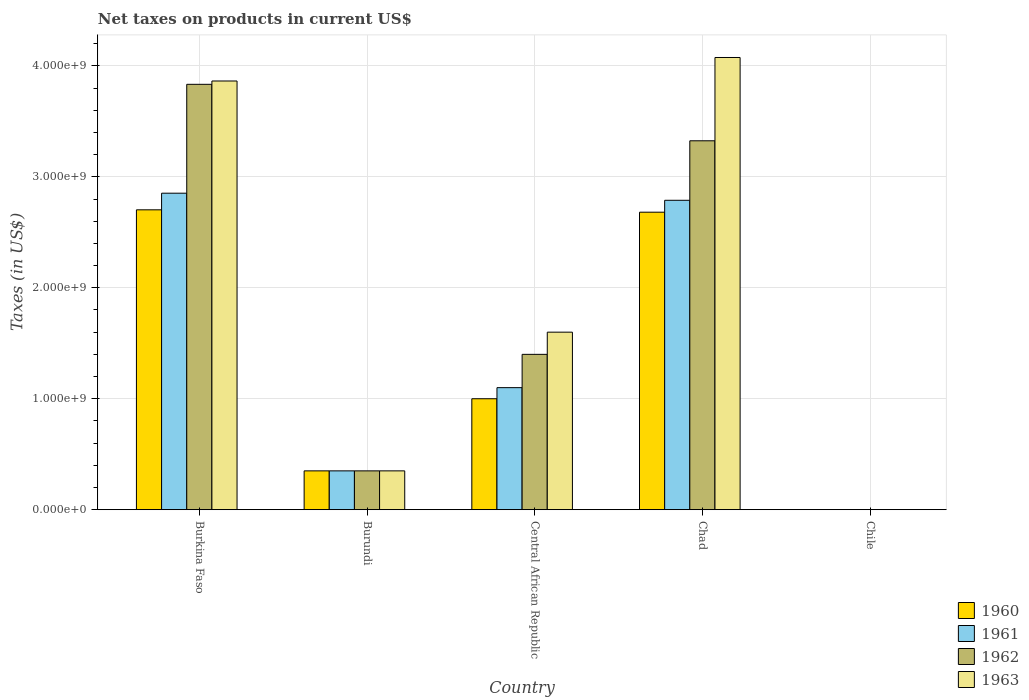How many groups of bars are there?
Ensure brevity in your answer.  5. Are the number of bars per tick equal to the number of legend labels?
Your answer should be compact. Yes. Are the number of bars on each tick of the X-axis equal?
Provide a succinct answer. Yes. What is the label of the 2nd group of bars from the left?
Keep it short and to the point. Burundi. In how many cases, is the number of bars for a given country not equal to the number of legend labels?
Offer a terse response. 0. What is the net taxes on products in 1963 in Chad?
Your answer should be compact. 4.08e+09. Across all countries, what is the maximum net taxes on products in 1962?
Provide a succinct answer. 3.83e+09. Across all countries, what is the minimum net taxes on products in 1962?
Provide a short and direct response. 2.53e+05. In which country was the net taxes on products in 1962 maximum?
Offer a terse response. Burkina Faso. In which country was the net taxes on products in 1963 minimum?
Offer a very short reply. Chile. What is the total net taxes on products in 1960 in the graph?
Ensure brevity in your answer.  6.73e+09. What is the difference between the net taxes on products in 1960 in Burundi and that in Central African Republic?
Offer a terse response. -6.50e+08. What is the difference between the net taxes on products in 1960 in Chile and the net taxes on products in 1962 in Central African Republic?
Keep it short and to the point. -1.40e+09. What is the average net taxes on products in 1962 per country?
Your response must be concise. 1.78e+09. What is the difference between the net taxes on products of/in 1963 and net taxes on products of/in 1962 in Burundi?
Your response must be concise. 0. In how many countries, is the net taxes on products in 1960 greater than 2000000000 US$?
Ensure brevity in your answer.  2. What is the ratio of the net taxes on products in 1963 in Burkina Faso to that in Chad?
Ensure brevity in your answer.  0.95. Is the net taxes on products in 1960 in Burkina Faso less than that in Chad?
Provide a succinct answer. No. What is the difference between the highest and the second highest net taxes on products in 1961?
Provide a short and direct response. 1.75e+09. What is the difference between the highest and the lowest net taxes on products in 1963?
Your response must be concise. 4.08e+09. Is it the case that in every country, the sum of the net taxes on products in 1960 and net taxes on products in 1961 is greater than the net taxes on products in 1963?
Offer a terse response. Yes. How many bars are there?
Keep it short and to the point. 20. How many countries are there in the graph?
Offer a terse response. 5. Are the values on the major ticks of Y-axis written in scientific E-notation?
Your answer should be compact. Yes. Does the graph contain any zero values?
Your answer should be compact. No. Does the graph contain grids?
Give a very brief answer. Yes. What is the title of the graph?
Offer a very short reply. Net taxes on products in current US$. What is the label or title of the Y-axis?
Give a very brief answer. Taxes (in US$). What is the Taxes (in US$) in 1960 in Burkina Faso?
Keep it short and to the point. 2.70e+09. What is the Taxes (in US$) in 1961 in Burkina Faso?
Your answer should be very brief. 2.85e+09. What is the Taxes (in US$) in 1962 in Burkina Faso?
Ensure brevity in your answer.  3.83e+09. What is the Taxes (in US$) in 1963 in Burkina Faso?
Your answer should be very brief. 3.86e+09. What is the Taxes (in US$) of 1960 in Burundi?
Give a very brief answer. 3.50e+08. What is the Taxes (in US$) of 1961 in Burundi?
Ensure brevity in your answer.  3.50e+08. What is the Taxes (in US$) of 1962 in Burundi?
Provide a succinct answer. 3.50e+08. What is the Taxes (in US$) in 1963 in Burundi?
Offer a terse response. 3.50e+08. What is the Taxes (in US$) in 1960 in Central African Republic?
Ensure brevity in your answer.  1.00e+09. What is the Taxes (in US$) of 1961 in Central African Republic?
Your response must be concise. 1.10e+09. What is the Taxes (in US$) in 1962 in Central African Republic?
Ensure brevity in your answer.  1.40e+09. What is the Taxes (in US$) of 1963 in Central African Republic?
Provide a succinct answer. 1.60e+09. What is the Taxes (in US$) of 1960 in Chad?
Your answer should be compact. 2.68e+09. What is the Taxes (in US$) of 1961 in Chad?
Provide a succinct answer. 2.79e+09. What is the Taxes (in US$) of 1962 in Chad?
Provide a short and direct response. 3.32e+09. What is the Taxes (in US$) of 1963 in Chad?
Give a very brief answer. 4.08e+09. What is the Taxes (in US$) of 1960 in Chile?
Give a very brief answer. 2.02e+05. What is the Taxes (in US$) of 1961 in Chile?
Your answer should be very brief. 2.53e+05. What is the Taxes (in US$) in 1962 in Chile?
Ensure brevity in your answer.  2.53e+05. What is the Taxes (in US$) in 1963 in Chile?
Your answer should be compact. 3.54e+05. Across all countries, what is the maximum Taxes (in US$) in 1960?
Provide a succinct answer. 2.70e+09. Across all countries, what is the maximum Taxes (in US$) in 1961?
Provide a succinct answer. 2.85e+09. Across all countries, what is the maximum Taxes (in US$) of 1962?
Provide a short and direct response. 3.83e+09. Across all countries, what is the maximum Taxes (in US$) in 1963?
Give a very brief answer. 4.08e+09. Across all countries, what is the minimum Taxes (in US$) of 1960?
Your answer should be compact. 2.02e+05. Across all countries, what is the minimum Taxes (in US$) of 1961?
Ensure brevity in your answer.  2.53e+05. Across all countries, what is the minimum Taxes (in US$) of 1962?
Ensure brevity in your answer.  2.53e+05. Across all countries, what is the minimum Taxes (in US$) of 1963?
Give a very brief answer. 3.54e+05. What is the total Taxes (in US$) of 1960 in the graph?
Your answer should be compact. 6.73e+09. What is the total Taxes (in US$) in 1961 in the graph?
Ensure brevity in your answer.  7.09e+09. What is the total Taxes (in US$) in 1962 in the graph?
Your answer should be very brief. 8.91e+09. What is the total Taxes (in US$) of 1963 in the graph?
Keep it short and to the point. 9.89e+09. What is the difference between the Taxes (in US$) in 1960 in Burkina Faso and that in Burundi?
Give a very brief answer. 2.35e+09. What is the difference between the Taxes (in US$) of 1961 in Burkina Faso and that in Burundi?
Your response must be concise. 2.50e+09. What is the difference between the Taxes (in US$) in 1962 in Burkina Faso and that in Burundi?
Keep it short and to the point. 3.48e+09. What is the difference between the Taxes (in US$) in 1963 in Burkina Faso and that in Burundi?
Your answer should be very brief. 3.51e+09. What is the difference between the Taxes (in US$) in 1960 in Burkina Faso and that in Central African Republic?
Ensure brevity in your answer.  1.70e+09. What is the difference between the Taxes (in US$) in 1961 in Burkina Faso and that in Central African Republic?
Ensure brevity in your answer.  1.75e+09. What is the difference between the Taxes (in US$) in 1962 in Burkina Faso and that in Central African Republic?
Ensure brevity in your answer.  2.43e+09. What is the difference between the Taxes (in US$) of 1963 in Burkina Faso and that in Central African Republic?
Keep it short and to the point. 2.26e+09. What is the difference between the Taxes (in US$) of 1960 in Burkina Faso and that in Chad?
Keep it short and to the point. 2.13e+07. What is the difference between the Taxes (in US$) in 1961 in Burkina Faso and that in Chad?
Provide a succinct answer. 6.39e+07. What is the difference between the Taxes (in US$) of 1962 in Burkina Faso and that in Chad?
Your response must be concise. 5.09e+08. What is the difference between the Taxes (in US$) in 1963 in Burkina Faso and that in Chad?
Give a very brief answer. -2.12e+08. What is the difference between the Taxes (in US$) of 1960 in Burkina Faso and that in Chile?
Provide a short and direct response. 2.70e+09. What is the difference between the Taxes (in US$) of 1961 in Burkina Faso and that in Chile?
Give a very brief answer. 2.85e+09. What is the difference between the Taxes (in US$) of 1962 in Burkina Faso and that in Chile?
Give a very brief answer. 3.83e+09. What is the difference between the Taxes (in US$) in 1963 in Burkina Faso and that in Chile?
Your answer should be very brief. 3.86e+09. What is the difference between the Taxes (in US$) in 1960 in Burundi and that in Central African Republic?
Make the answer very short. -6.50e+08. What is the difference between the Taxes (in US$) of 1961 in Burundi and that in Central African Republic?
Offer a very short reply. -7.50e+08. What is the difference between the Taxes (in US$) of 1962 in Burundi and that in Central African Republic?
Make the answer very short. -1.05e+09. What is the difference between the Taxes (in US$) in 1963 in Burundi and that in Central African Republic?
Your answer should be very brief. -1.25e+09. What is the difference between the Taxes (in US$) in 1960 in Burundi and that in Chad?
Ensure brevity in your answer.  -2.33e+09. What is the difference between the Taxes (in US$) of 1961 in Burundi and that in Chad?
Your answer should be compact. -2.44e+09. What is the difference between the Taxes (in US$) in 1962 in Burundi and that in Chad?
Keep it short and to the point. -2.97e+09. What is the difference between the Taxes (in US$) of 1963 in Burundi and that in Chad?
Offer a terse response. -3.73e+09. What is the difference between the Taxes (in US$) of 1960 in Burundi and that in Chile?
Provide a succinct answer. 3.50e+08. What is the difference between the Taxes (in US$) of 1961 in Burundi and that in Chile?
Your response must be concise. 3.50e+08. What is the difference between the Taxes (in US$) in 1962 in Burundi and that in Chile?
Offer a very short reply. 3.50e+08. What is the difference between the Taxes (in US$) in 1963 in Burundi and that in Chile?
Offer a very short reply. 3.50e+08. What is the difference between the Taxes (in US$) of 1960 in Central African Republic and that in Chad?
Provide a short and direct response. -1.68e+09. What is the difference between the Taxes (in US$) in 1961 in Central African Republic and that in Chad?
Provide a succinct answer. -1.69e+09. What is the difference between the Taxes (in US$) of 1962 in Central African Republic and that in Chad?
Offer a very short reply. -1.92e+09. What is the difference between the Taxes (in US$) of 1963 in Central African Republic and that in Chad?
Your response must be concise. -2.48e+09. What is the difference between the Taxes (in US$) of 1960 in Central African Republic and that in Chile?
Provide a short and direct response. 1.00e+09. What is the difference between the Taxes (in US$) of 1961 in Central African Republic and that in Chile?
Offer a terse response. 1.10e+09. What is the difference between the Taxes (in US$) in 1962 in Central African Republic and that in Chile?
Your response must be concise. 1.40e+09. What is the difference between the Taxes (in US$) of 1963 in Central African Republic and that in Chile?
Keep it short and to the point. 1.60e+09. What is the difference between the Taxes (in US$) in 1960 in Chad and that in Chile?
Keep it short and to the point. 2.68e+09. What is the difference between the Taxes (in US$) in 1961 in Chad and that in Chile?
Offer a terse response. 2.79e+09. What is the difference between the Taxes (in US$) of 1962 in Chad and that in Chile?
Make the answer very short. 3.32e+09. What is the difference between the Taxes (in US$) of 1963 in Chad and that in Chile?
Give a very brief answer. 4.08e+09. What is the difference between the Taxes (in US$) of 1960 in Burkina Faso and the Taxes (in US$) of 1961 in Burundi?
Offer a very short reply. 2.35e+09. What is the difference between the Taxes (in US$) in 1960 in Burkina Faso and the Taxes (in US$) in 1962 in Burundi?
Your response must be concise. 2.35e+09. What is the difference between the Taxes (in US$) of 1960 in Burkina Faso and the Taxes (in US$) of 1963 in Burundi?
Your answer should be very brief. 2.35e+09. What is the difference between the Taxes (in US$) of 1961 in Burkina Faso and the Taxes (in US$) of 1962 in Burundi?
Your answer should be very brief. 2.50e+09. What is the difference between the Taxes (in US$) of 1961 in Burkina Faso and the Taxes (in US$) of 1963 in Burundi?
Make the answer very short. 2.50e+09. What is the difference between the Taxes (in US$) in 1962 in Burkina Faso and the Taxes (in US$) in 1963 in Burundi?
Provide a short and direct response. 3.48e+09. What is the difference between the Taxes (in US$) of 1960 in Burkina Faso and the Taxes (in US$) of 1961 in Central African Republic?
Give a very brief answer. 1.60e+09. What is the difference between the Taxes (in US$) of 1960 in Burkina Faso and the Taxes (in US$) of 1962 in Central African Republic?
Your response must be concise. 1.30e+09. What is the difference between the Taxes (in US$) of 1960 in Burkina Faso and the Taxes (in US$) of 1963 in Central African Republic?
Offer a terse response. 1.10e+09. What is the difference between the Taxes (in US$) of 1961 in Burkina Faso and the Taxes (in US$) of 1962 in Central African Republic?
Give a very brief answer. 1.45e+09. What is the difference between the Taxes (in US$) of 1961 in Burkina Faso and the Taxes (in US$) of 1963 in Central African Republic?
Give a very brief answer. 1.25e+09. What is the difference between the Taxes (in US$) of 1962 in Burkina Faso and the Taxes (in US$) of 1963 in Central African Republic?
Make the answer very short. 2.23e+09. What is the difference between the Taxes (in US$) in 1960 in Burkina Faso and the Taxes (in US$) in 1961 in Chad?
Your answer should be very brief. -8.59e+07. What is the difference between the Taxes (in US$) of 1960 in Burkina Faso and the Taxes (in US$) of 1962 in Chad?
Make the answer very short. -6.22e+08. What is the difference between the Taxes (in US$) in 1960 in Burkina Faso and the Taxes (in US$) in 1963 in Chad?
Keep it short and to the point. -1.37e+09. What is the difference between the Taxes (in US$) in 1961 in Burkina Faso and the Taxes (in US$) in 1962 in Chad?
Give a very brief answer. -4.72e+08. What is the difference between the Taxes (in US$) of 1961 in Burkina Faso and the Taxes (in US$) of 1963 in Chad?
Your answer should be very brief. -1.22e+09. What is the difference between the Taxes (in US$) in 1962 in Burkina Faso and the Taxes (in US$) in 1963 in Chad?
Provide a succinct answer. -2.42e+08. What is the difference between the Taxes (in US$) in 1960 in Burkina Faso and the Taxes (in US$) in 1961 in Chile?
Provide a succinct answer. 2.70e+09. What is the difference between the Taxes (in US$) in 1960 in Burkina Faso and the Taxes (in US$) in 1962 in Chile?
Your response must be concise. 2.70e+09. What is the difference between the Taxes (in US$) of 1960 in Burkina Faso and the Taxes (in US$) of 1963 in Chile?
Give a very brief answer. 2.70e+09. What is the difference between the Taxes (in US$) of 1961 in Burkina Faso and the Taxes (in US$) of 1962 in Chile?
Keep it short and to the point. 2.85e+09. What is the difference between the Taxes (in US$) of 1961 in Burkina Faso and the Taxes (in US$) of 1963 in Chile?
Provide a short and direct response. 2.85e+09. What is the difference between the Taxes (in US$) of 1962 in Burkina Faso and the Taxes (in US$) of 1963 in Chile?
Keep it short and to the point. 3.83e+09. What is the difference between the Taxes (in US$) in 1960 in Burundi and the Taxes (in US$) in 1961 in Central African Republic?
Provide a succinct answer. -7.50e+08. What is the difference between the Taxes (in US$) of 1960 in Burundi and the Taxes (in US$) of 1962 in Central African Republic?
Offer a terse response. -1.05e+09. What is the difference between the Taxes (in US$) in 1960 in Burundi and the Taxes (in US$) in 1963 in Central African Republic?
Give a very brief answer. -1.25e+09. What is the difference between the Taxes (in US$) in 1961 in Burundi and the Taxes (in US$) in 1962 in Central African Republic?
Provide a succinct answer. -1.05e+09. What is the difference between the Taxes (in US$) of 1961 in Burundi and the Taxes (in US$) of 1963 in Central African Republic?
Provide a succinct answer. -1.25e+09. What is the difference between the Taxes (in US$) of 1962 in Burundi and the Taxes (in US$) of 1963 in Central African Republic?
Give a very brief answer. -1.25e+09. What is the difference between the Taxes (in US$) of 1960 in Burundi and the Taxes (in US$) of 1961 in Chad?
Your response must be concise. -2.44e+09. What is the difference between the Taxes (in US$) in 1960 in Burundi and the Taxes (in US$) in 1962 in Chad?
Your answer should be very brief. -2.97e+09. What is the difference between the Taxes (in US$) of 1960 in Burundi and the Taxes (in US$) of 1963 in Chad?
Offer a terse response. -3.73e+09. What is the difference between the Taxes (in US$) in 1961 in Burundi and the Taxes (in US$) in 1962 in Chad?
Provide a short and direct response. -2.97e+09. What is the difference between the Taxes (in US$) of 1961 in Burundi and the Taxes (in US$) of 1963 in Chad?
Give a very brief answer. -3.73e+09. What is the difference between the Taxes (in US$) in 1962 in Burundi and the Taxes (in US$) in 1963 in Chad?
Make the answer very short. -3.73e+09. What is the difference between the Taxes (in US$) of 1960 in Burundi and the Taxes (in US$) of 1961 in Chile?
Provide a succinct answer. 3.50e+08. What is the difference between the Taxes (in US$) in 1960 in Burundi and the Taxes (in US$) in 1962 in Chile?
Keep it short and to the point. 3.50e+08. What is the difference between the Taxes (in US$) in 1960 in Burundi and the Taxes (in US$) in 1963 in Chile?
Your answer should be very brief. 3.50e+08. What is the difference between the Taxes (in US$) of 1961 in Burundi and the Taxes (in US$) of 1962 in Chile?
Offer a very short reply. 3.50e+08. What is the difference between the Taxes (in US$) in 1961 in Burundi and the Taxes (in US$) in 1963 in Chile?
Provide a short and direct response. 3.50e+08. What is the difference between the Taxes (in US$) of 1962 in Burundi and the Taxes (in US$) of 1963 in Chile?
Keep it short and to the point. 3.50e+08. What is the difference between the Taxes (in US$) in 1960 in Central African Republic and the Taxes (in US$) in 1961 in Chad?
Provide a short and direct response. -1.79e+09. What is the difference between the Taxes (in US$) of 1960 in Central African Republic and the Taxes (in US$) of 1962 in Chad?
Your response must be concise. -2.32e+09. What is the difference between the Taxes (in US$) in 1960 in Central African Republic and the Taxes (in US$) in 1963 in Chad?
Provide a short and direct response. -3.08e+09. What is the difference between the Taxes (in US$) of 1961 in Central African Republic and the Taxes (in US$) of 1962 in Chad?
Give a very brief answer. -2.22e+09. What is the difference between the Taxes (in US$) in 1961 in Central African Republic and the Taxes (in US$) in 1963 in Chad?
Ensure brevity in your answer.  -2.98e+09. What is the difference between the Taxes (in US$) of 1962 in Central African Republic and the Taxes (in US$) of 1963 in Chad?
Offer a terse response. -2.68e+09. What is the difference between the Taxes (in US$) of 1960 in Central African Republic and the Taxes (in US$) of 1961 in Chile?
Your response must be concise. 1.00e+09. What is the difference between the Taxes (in US$) in 1960 in Central African Republic and the Taxes (in US$) in 1962 in Chile?
Give a very brief answer. 1.00e+09. What is the difference between the Taxes (in US$) of 1960 in Central African Republic and the Taxes (in US$) of 1963 in Chile?
Offer a terse response. 1.00e+09. What is the difference between the Taxes (in US$) of 1961 in Central African Republic and the Taxes (in US$) of 1962 in Chile?
Your answer should be compact. 1.10e+09. What is the difference between the Taxes (in US$) of 1961 in Central African Republic and the Taxes (in US$) of 1963 in Chile?
Offer a terse response. 1.10e+09. What is the difference between the Taxes (in US$) of 1962 in Central African Republic and the Taxes (in US$) of 1963 in Chile?
Make the answer very short. 1.40e+09. What is the difference between the Taxes (in US$) of 1960 in Chad and the Taxes (in US$) of 1961 in Chile?
Make the answer very short. 2.68e+09. What is the difference between the Taxes (in US$) of 1960 in Chad and the Taxes (in US$) of 1962 in Chile?
Ensure brevity in your answer.  2.68e+09. What is the difference between the Taxes (in US$) in 1960 in Chad and the Taxes (in US$) in 1963 in Chile?
Your answer should be very brief. 2.68e+09. What is the difference between the Taxes (in US$) of 1961 in Chad and the Taxes (in US$) of 1962 in Chile?
Keep it short and to the point. 2.79e+09. What is the difference between the Taxes (in US$) of 1961 in Chad and the Taxes (in US$) of 1963 in Chile?
Make the answer very short. 2.79e+09. What is the difference between the Taxes (in US$) in 1962 in Chad and the Taxes (in US$) in 1963 in Chile?
Give a very brief answer. 3.32e+09. What is the average Taxes (in US$) of 1960 per country?
Give a very brief answer. 1.35e+09. What is the average Taxes (in US$) of 1961 per country?
Your answer should be very brief. 1.42e+09. What is the average Taxes (in US$) of 1962 per country?
Offer a very short reply. 1.78e+09. What is the average Taxes (in US$) of 1963 per country?
Your answer should be very brief. 1.98e+09. What is the difference between the Taxes (in US$) of 1960 and Taxes (in US$) of 1961 in Burkina Faso?
Make the answer very short. -1.50e+08. What is the difference between the Taxes (in US$) of 1960 and Taxes (in US$) of 1962 in Burkina Faso?
Offer a very short reply. -1.13e+09. What is the difference between the Taxes (in US$) of 1960 and Taxes (in US$) of 1963 in Burkina Faso?
Provide a short and direct response. -1.16e+09. What is the difference between the Taxes (in US$) in 1961 and Taxes (in US$) in 1962 in Burkina Faso?
Your answer should be very brief. -9.81e+08. What is the difference between the Taxes (in US$) in 1961 and Taxes (in US$) in 1963 in Burkina Faso?
Make the answer very short. -1.01e+09. What is the difference between the Taxes (in US$) in 1962 and Taxes (in US$) in 1963 in Burkina Faso?
Ensure brevity in your answer.  -3.00e+07. What is the difference between the Taxes (in US$) of 1960 and Taxes (in US$) of 1963 in Burundi?
Provide a succinct answer. 0. What is the difference between the Taxes (in US$) of 1961 and Taxes (in US$) of 1963 in Burundi?
Your answer should be very brief. 0. What is the difference between the Taxes (in US$) in 1962 and Taxes (in US$) in 1963 in Burundi?
Provide a succinct answer. 0. What is the difference between the Taxes (in US$) of 1960 and Taxes (in US$) of 1961 in Central African Republic?
Provide a succinct answer. -1.00e+08. What is the difference between the Taxes (in US$) in 1960 and Taxes (in US$) in 1962 in Central African Republic?
Ensure brevity in your answer.  -4.00e+08. What is the difference between the Taxes (in US$) in 1960 and Taxes (in US$) in 1963 in Central African Republic?
Provide a short and direct response. -6.00e+08. What is the difference between the Taxes (in US$) of 1961 and Taxes (in US$) of 1962 in Central African Republic?
Offer a terse response. -3.00e+08. What is the difference between the Taxes (in US$) of 1961 and Taxes (in US$) of 1963 in Central African Republic?
Make the answer very short. -5.00e+08. What is the difference between the Taxes (in US$) of 1962 and Taxes (in US$) of 1963 in Central African Republic?
Keep it short and to the point. -2.00e+08. What is the difference between the Taxes (in US$) of 1960 and Taxes (in US$) of 1961 in Chad?
Your answer should be very brief. -1.07e+08. What is the difference between the Taxes (in US$) of 1960 and Taxes (in US$) of 1962 in Chad?
Offer a very short reply. -6.44e+08. What is the difference between the Taxes (in US$) in 1960 and Taxes (in US$) in 1963 in Chad?
Ensure brevity in your answer.  -1.39e+09. What is the difference between the Taxes (in US$) in 1961 and Taxes (in US$) in 1962 in Chad?
Give a very brief answer. -5.36e+08. What is the difference between the Taxes (in US$) of 1961 and Taxes (in US$) of 1963 in Chad?
Your answer should be compact. -1.29e+09. What is the difference between the Taxes (in US$) of 1962 and Taxes (in US$) of 1963 in Chad?
Your answer should be very brief. -7.51e+08. What is the difference between the Taxes (in US$) of 1960 and Taxes (in US$) of 1961 in Chile?
Provide a short and direct response. -5.06e+04. What is the difference between the Taxes (in US$) of 1960 and Taxes (in US$) of 1962 in Chile?
Your answer should be very brief. -5.06e+04. What is the difference between the Taxes (in US$) of 1960 and Taxes (in US$) of 1963 in Chile?
Provide a succinct answer. -1.52e+05. What is the difference between the Taxes (in US$) of 1961 and Taxes (in US$) of 1962 in Chile?
Make the answer very short. 0. What is the difference between the Taxes (in US$) of 1961 and Taxes (in US$) of 1963 in Chile?
Your answer should be very brief. -1.01e+05. What is the difference between the Taxes (in US$) in 1962 and Taxes (in US$) in 1963 in Chile?
Ensure brevity in your answer.  -1.01e+05. What is the ratio of the Taxes (in US$) in 1960 in Burkina Faso to that in Burundi?
Offer a very short reply. 7.72. What is the ratio of the Taxes (in US$) in 1961 in Burkina Faso to that in Burundi?
Make the answer very short. 8.15. What is the ratio of the Taxes (in US$) in 1962 in Burkina Faso to that in Burundi?
Keep it short and to the point. 10.95. What is the ratio of the Taxes (in US$) of 1963 in Burkina Faso to that in Burundi?
Give a very brief answer. 11.04. What is the ratio of the Taxes (in US$) in 1960 in Burkina Faso to that in Central African Republic?
Ensure brevity in your answer.  2.7. What is the ratio of the Taxes (in US$) in 1961 in Burkina Faso to that in Central African Republic?
Your answer should be compact. 2.59. What is the ratio of the Taxes (in US$) of 1962 in Burkina Faso to that in Central African Republic?
Your response must be concise. 2.74. What is the ratio of the Taxes (in US$) of 1963 in Burkina Faso to that in Central African Republic?
Provide a succinct answer. 2.41. What is the ratio of the Taxes (in US$) of 1961 in Burkina Faso to that in Chad?
Your answer should be compact. 1.02. What is the ratio of the Taxes (in US$) of 1962 in Burkina Faso to that in Chad?
Make the answer very short. 1.15. What is the ratio of the Taxes (in US$) of 1963 in Burkina Faso to that in Chad?
Make the answer very short. 0.95. What is the ratio of the Taxes (in US$) in 1960 in Burkina Faso to that in Chile?
Keep it short and to the point. 1.33e+04. What is the ratio of the Taxes (in US$) of 1961 in Burkina Faso to that in Chile?
Provide a short and direct response. 1.13e+04. What is the ratio of the Taxes (in US$) of 1962 in Burkina Faso to that in Chile?
Ensure brevity in your answer.  1.51e+04. What is the ratio of the Taxes (in US$) in 1963 in Burkina Faso to that in Chile?
Give a very brief answer. 1.09e+04. What is the ratio of the Taxes (in US$) in 1960 in Burundi to that in Central African Republic?
Provide a short and direct response. 0.35. What is the ratio of the Taxes (in US$) in 1961 in Burundi to that in Central African Republic?
Offer a terse response. 0.32. What is the ratio of the Taxes (in US$) in 1963 in Burundi to that in Central African Republic?
Your answer should be very brief. 0.22. What is the ratio of the Taxes (in US$) of 1960 in Burundi to that in Chad?
Make the answer very short. 0.13. What is the ratio of the Taxes (in US$) of 1961 in Burundi to that in Chad?
Your response must be concise. 0.13. What is the ratio of the Taxes (in US$) in 1962 in Burundi to that in Chad?
Offer a very short reply. 0.11. What is the ratio of the Taxes (in US$) of 1963 in Burundi to that in Chad?
Give a very brief answer. 0.09. What is the ratio of the Taxes (in US$) of 1960 in Burundi to that in Chile?
Your answer should be very brief. 1728.4. What is the ratio of the Taxes (in US$) in 1961 in Burundi to that in Chile?
Keep it short and to the point. 1382.85. What is the ratio of the Taxes (in US$) in 1962 in Burundi to that in Chile?
Provide a short and direct response. 1382.85. What is the ratio of the Taxes (in US$) of 1963 in Burundi to that in Chile?
Give a very brief answer. 987.58. What is the ratio of the Taxes (in US$) of 1960 in Central African Republic to that in Chad?
Offer a very short reply. 0.37. What is the ratio of the Taxes (in US$) of 1961 in Central African Republic to that in Chad?
Your response must be concise. 0.39. What is the ratio of the Taxes (in US$) in 1962 in Central African Republic to that in Chad?
Offer a very short reply. 0.42. What is the ratio of the Taxes (in US$) in 1963 in Central African Republic to that in Chad?
Your response must be concise. 0.39. What is the ratio of the Taxes (in US$) of 1960 in Central African Republic to that in Chile?
Give a very brief answer. 4938.27. What is the ratio of the Taxes (in US$) of 1961 in Central African Republic to that in Chile?
Keep it short and to the point. 4346.11. What is the ratio of the Taxes (in US$) of 1962 in Central African Republic to that in Chile?
Provide a short and direct response. 5531.41. What is the ratio of the Taxes (in US$) of 1963 in Central African Republic to that in Chile?
Ensure brevity in your answer.  4514.67. What is the ratio of the Taxes (in US$) in 1960 in Chad to that in Chile?
Provide a short and direct response. 1.32e+04. What is the ratio of the Taxes (in US$) of 1961 in Chad to that in Chile?
Your answer should be compact. 1.10e+04. What is the ratio of the Taxes (in US$) in 1962 in Chad to that in Chile?
Your response must be concise. 1.31e+04. What is the ratio of the Taxes (in US$) in 1963 in Chad to that in Chile?
Provide a short and direct response. 1.15e+04. What is the difference between the highest and the second highest Taxes (in US$) in 1960?
Provide a short and direct response. 2.13e+07. What is the difference between the highest and the second highest Taxes (in US$) in 1961?
Give a very brief answer. 6.39e+07. What is the difference between the highest and the second highest Taxes (in US$) of 1962?
Provide a short and direct response. 5.09e+08. What is the difference between the highest and the second highest Taxes (in US$) in 1963?
Provide a succinct answer. 2.12e+08. What is the difference between the highest and the lowest Taxes (in US$) in 1960?
Make the answer very short. 2.70e+09. What is the difference between the highest and the lowest Taxes (in US$) in 1961?
Keep it short and to the point. 2.85e+09. What is the difference between the highest and the lowest Taxes (in US$) in 1962?
Your answer should be very brief. 3.83e+09. What is the difference between the highest and the lowest Taxes (in US$) of 1963?
Offer a terse response. 4.08e+09. 